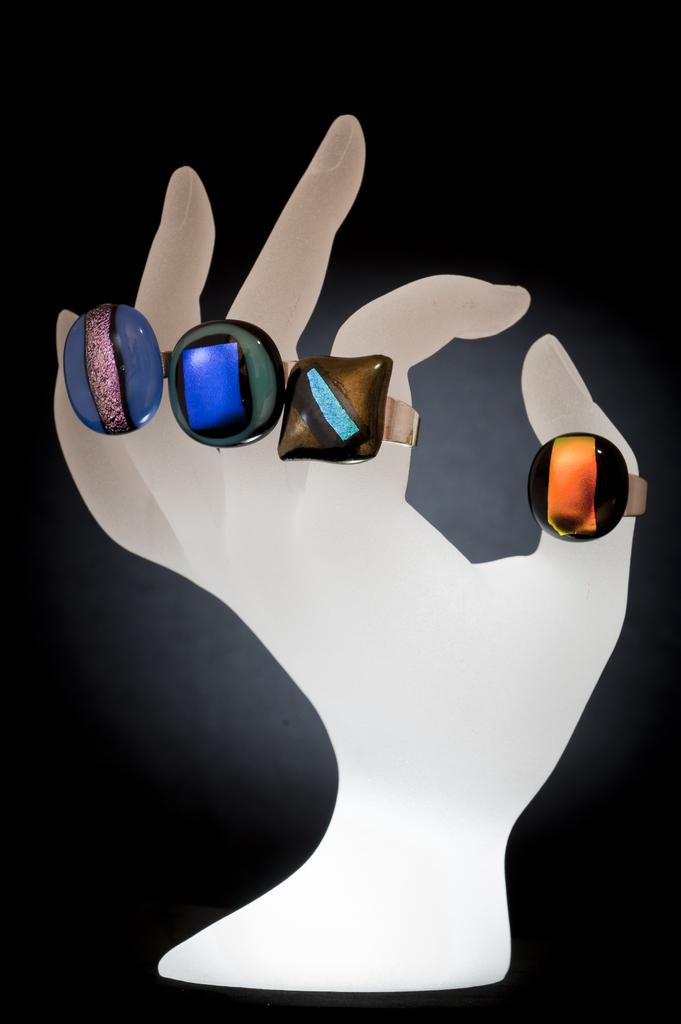What type of image is being described? The image is animated. What can be seen in the animated image? There is a statue of a hand in the image. What detail can be observed about the statue? The statue has rings on its fingers. What color is the background of the image? The background of the image is black. Can you describe the stream of water flowing near the statue in the image? There is no stream of water present in the image; it features a statue of a hand with rings on its fingers against a black background. What type of bird can be seen perched on the statue's shoulder in the image? There is no bird present in the image; it only features a statue of a hand with rings on its fingers against a black background. 